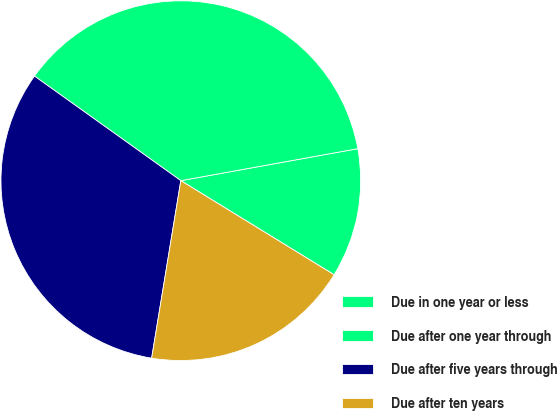Convert chart. <chart><loc_0><loc_0><loc_500><loc_500><pie_chart><fcel>Due in one year or less<fcel>Due after one year through<fcel>Due after five years through<fcel>Due after ten years<nl><fcel>11.61%<fcel>37.28%<fcel>32.28%<fcel>18.83%<nl></chart> 